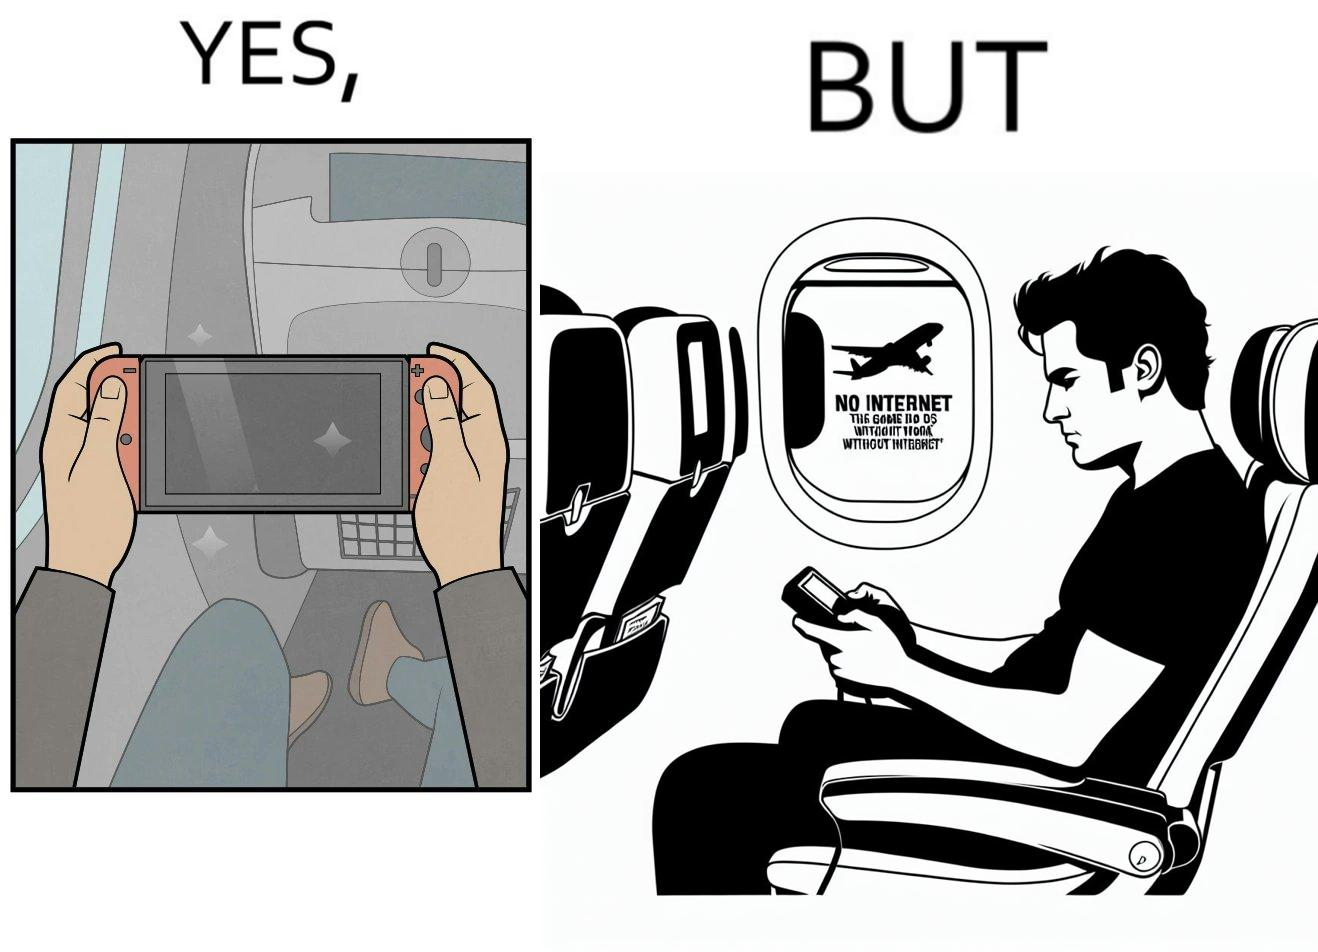Is this a satirical image? Yes, this image is satirical. 